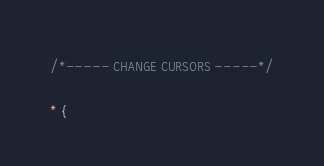<code> <loc_0><loc_0><loc_500><loc_500><_CSS_>/*----- CHANGE CURSORS -----*/
 
* {</code> 